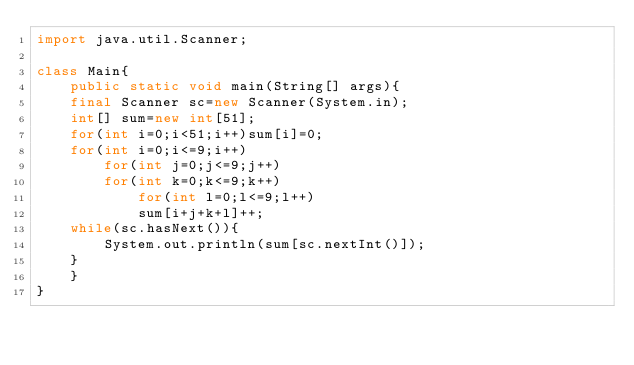<code> <loc_0><loc_0><loc_500><loc_500><_Java_>import java.util.Scanner;

class Main{
    public static void main(String[] args){
	final Scanner sc=new Scanner(System.in);
	int[] sum=new int[51];
	for(int i=0;i<51;i++)sum[i]=0;
	for(int i=0;i<=9;i++)
	    for(int j=0;j<=9;j++)
		for(int k=0;k<=9;k++)
		    for(int l=0;l<=9;l++)
			sum[i+j+k+l]++;
	while(sc.hasNext()){
	    System.out.println(sum[sc.nextInt()]);
	}
    }
}</code> 